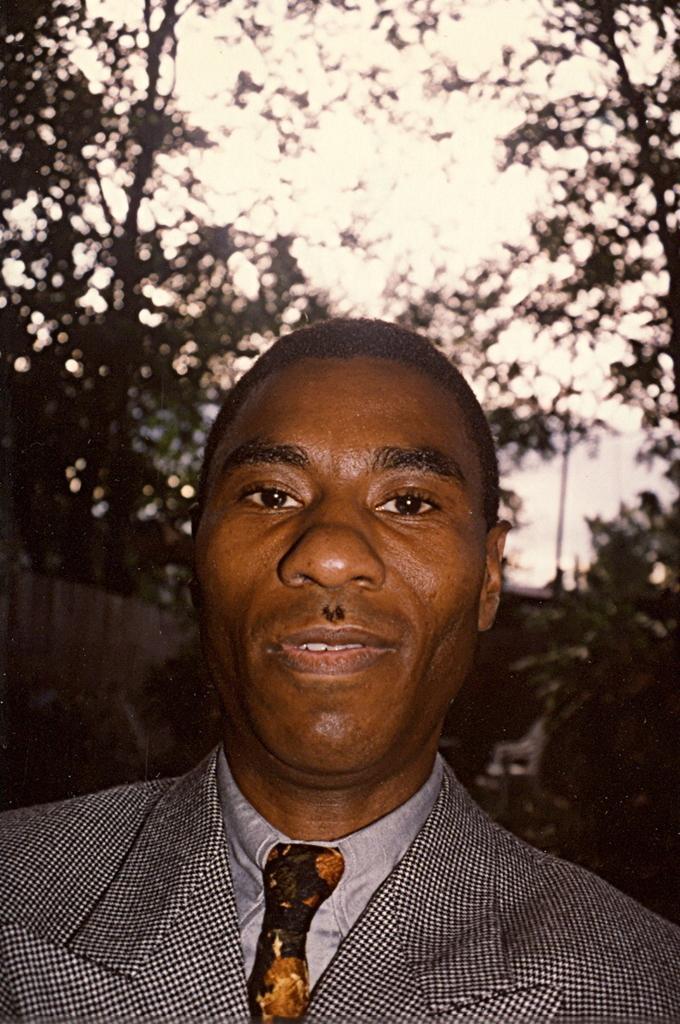Could you give a brief overview of what you see in this image? In this picture we can see a man in the front, in the background there are trees, we can see the sky at the top of the picture. 